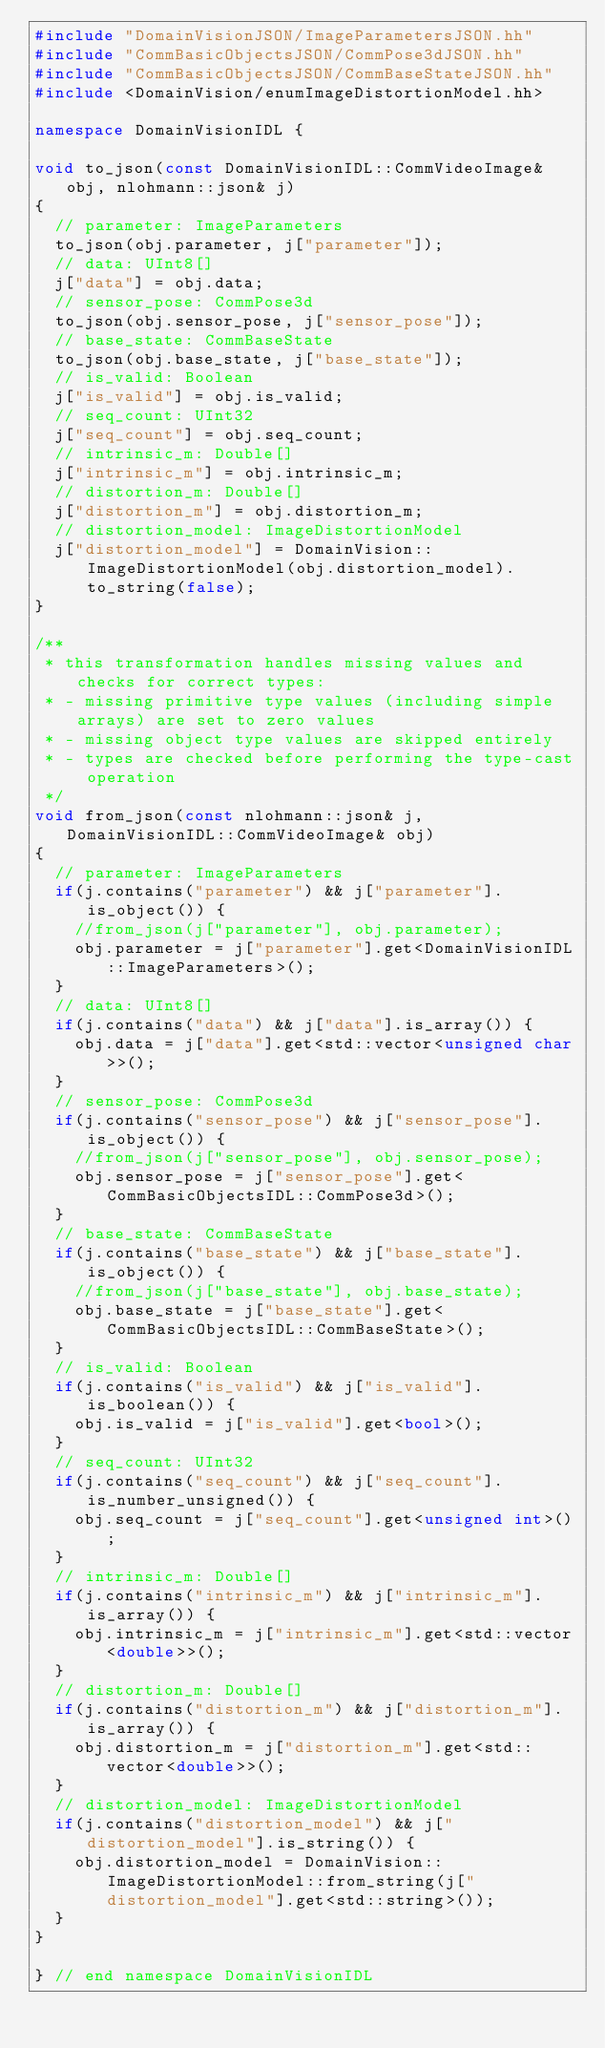<code> <loc_0><loc_0><loc_500><loc_500><_C++_>#include "DomainVisionJSON/ImageParametersJSON.hh"
#include "CommBasicObjectsJSON/CommPose3dJSON.hh"
#include "CommBasicObjectsJSON/CommBaseStateJSON.hh"
#include <DomainVision/enumImageDistortionModel.hh>

namespace DomainVisionIDL {

void to_json(const DomainVisionIDL::CommVideoImage& obj, nlohmann::json& j)
{
	// parameter: ImageParameters
	to_json(obj.parameter, j["parameter"]);
	// data: UInt8[]
	j["data"] = obj.data;
	// sensor_pose: CommPose3d
	to_json(obj.sensor_pose, j["sensor_pose"]);
	// base_state: CommBaseState
	to_json(obj.base_state, j["base_state"]);
	// is_valid: Boolean
	j["is_valid"] = obj.is_valid;
	// seq_count: UInt32
	j["seq_count"] = obj.seq_count;
	// intrinsic_m: Double[]
	j["intrinsic_m"] = obj.intrinsic_m;
	// distortion_m: Double[]
	j["distortion_m"] = obj.distortion_m;
	// distortion_model: ImageDistortionModel
	j["distortion_model"] = DomainVision::ImageDistortionModel(obj.distortion_model).to_string(false);
}

/**
 * this transformation handles missing values and checks for correct types:
 * - missing primitive type values (including simple arrays) are set to zero values
 * - missing object type values are skipped entirely
 * - types are checked before performing the type-cast operation
 */
void from_json(const nlohmann::json& j, DomainVisionIDL::CommVideoImage& obj)
{
	// parameter: ImageParameters
	if(j.contains("parameter") && j["parameter"].is_object()) {
		//from_json(j["parameter"], obj.parameter);
		obj.parameter = j["parameter"].get<DomainVisionIDL::ImageParameters>();
	}
	// data: UInt8[]
	if(j.contains("data") && j["data"].is_array()) {
		obj.data = j["data"].get<std::vector<unsigned char>>();
	}
	// sensor_pose: CommPose3d
	if(j.contains("sensor_pose") && j["sensor_pose"].is_object()) {
		//from_json(j["sensor_pose"], obj.sensor_pose);
		obj.sensor_pose = j["sensor_pose"].get<CommBasicObjectsIDL::CommPose3d>();
	}
	// base_state: CommBaseState
	if(j.contains("base_state") && j["base_state"].is_object()) {
		//from_json(j["base_state"], obj.base_state);
		obj.base_state = j["base_state"].get<CommBasicObjectsIDL::CommBaseState>();
	}
	// is_valid: Boolean
	if(j.contains("is_valid") && j["is_valid"].is_boolean()) {
		obj.is_valid = j["is_valid"].get<bool>();
	}
	// seq_count: UInt32
	if(j.contains("seq_count") && j["seq_count"].is_number_unsigned()) {
		obj.seq_count = j["seq_count"].get<unsigned int>();
	}
	// intrinsic_m: Double[]
	if(j.contains("intrinsic_m") && j["intrinsic_m"].is_array()) {
		obj.intrinsic_m = j["intrinsic_m"].get<std::vector<double>>();
	}
	// distortion_m: Double[]
	if(j.contains("distortion_m") && j["distortion_m"].is_array()) {
		obj.distortion_m = j["distortion_m"].get<std::vector<double>>();
	}
	// distortion_model: ImageDistortionModel
	if(j.contains("distortion_model") && j["distortion_model"].is_string()) {
		obj.distortion_model = DomainVision::ImageDistortionModel::from_string(j["distortion_model"].get<std::string>());
	}
}

} // end namespace DomainVisionIDL
</code> 